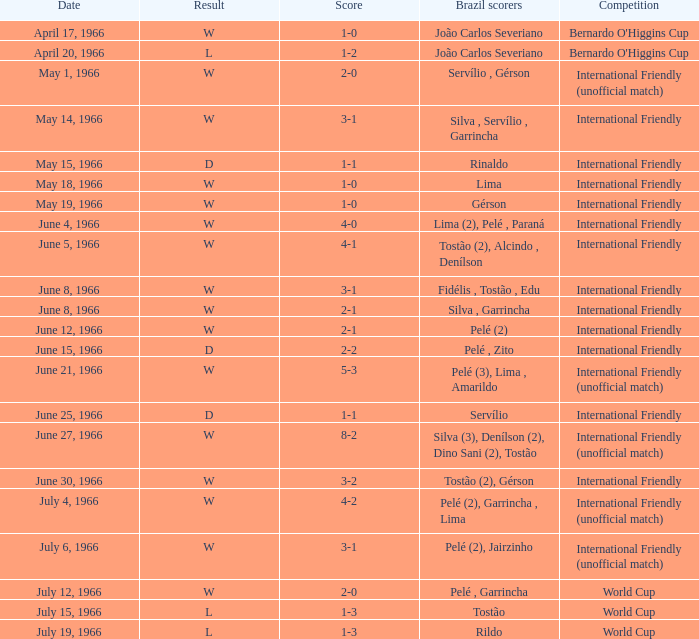What is the result when the score is 4-0? W. Could you help me parse every detail presented in this table? {'header': ['Date', 'Result', 'Score', 'Brazil scorers', 'Competition'], 'rows': [['April 17, 1966', 'W', '1-0', 'João Carlos Severiano', "Bernardo O'Higgins Cup"], ['April 20, 1966', 'L', '1-2', 'João Carlos Severiano', "Bernardo O'Higgins Cup"], ['May 1, 1966', 'W', '2-0', 'Servílio , Gérson', 'International Friendly (unofficial match)'], ['May 14, 1966', 'W', '3-1', 'Silva , Servílio , Garrincha', 'International Friendly'], ['May 15, 1966', 'D', '1-1', 'Rinaldo', 'International Friendly'], ['May 18, 1966', 'W', '1-0', 'Lima', 'International Friendly'], ['May 19, 1966', 'W', '1-0', 'Gérson', 'International Friendly'], ['June 4, 1966', 'W', '4-0', 'Lima (2), Pelé , Paraná', 'International Friendly'], ['June 5, 1966', 'W', '4-1', 'Tostão (2), Alcindo , Denílson', 'International Friendly'], ['June 8, 1966', 'W', '3-1', 'Fidélis , Tostão , Edu', 'International Friendly'], ['June 8, 1966', 'W', '2-1', 'Silva , Garrincha', 'International Friendly'], ['June 12, 1966', 'W', '2-1', 'Pelé (2)', 'International Friendly'], ['June 15, 1966', 'D', '2-2', 'Pelé , Zito', 'International Friendly'], ['June 21, 1966', 'W', '5-3', 'Pelé (3), Lima , Amarildo', 'International Friendly (unofficial match)'], ['June 25, 1966', 'D', '1-1', 'Servílio', 'International Friendly'], ['June 27, 1966', 'W', '8-2', 'Silva (3), Denílson (2), Dino Sani (2), Tostão', 'International Friendly (unofficial match)'], ['June 30, 1966', 'W', '3-2', 'Tostão (2), Gérson', 'International Friendly'], ['July 4, 1966', 'W', '4-2', 'Pelé (2), Garrincha , Lima', 'International Friendly (unofficial match)'], ['July 6, 1966', 'W', '3-1', 'Pelé (2), Jairzinho', 'International Friendly (unofficial match)'], ['July 12, 1966', 'W', '2-0', 'Pelé , Garrincha', 'World Cup'], ['July 15, 1966', 'L', '1-3', 'Tostão', 'World Cup'], ['July 19, 1966', 'L', '1-3', 'Rildo', 'World Cup']]} 